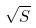<formula> <loc_0><loc_0><loc_500><loc_500>\sqrt { S }</formula> 